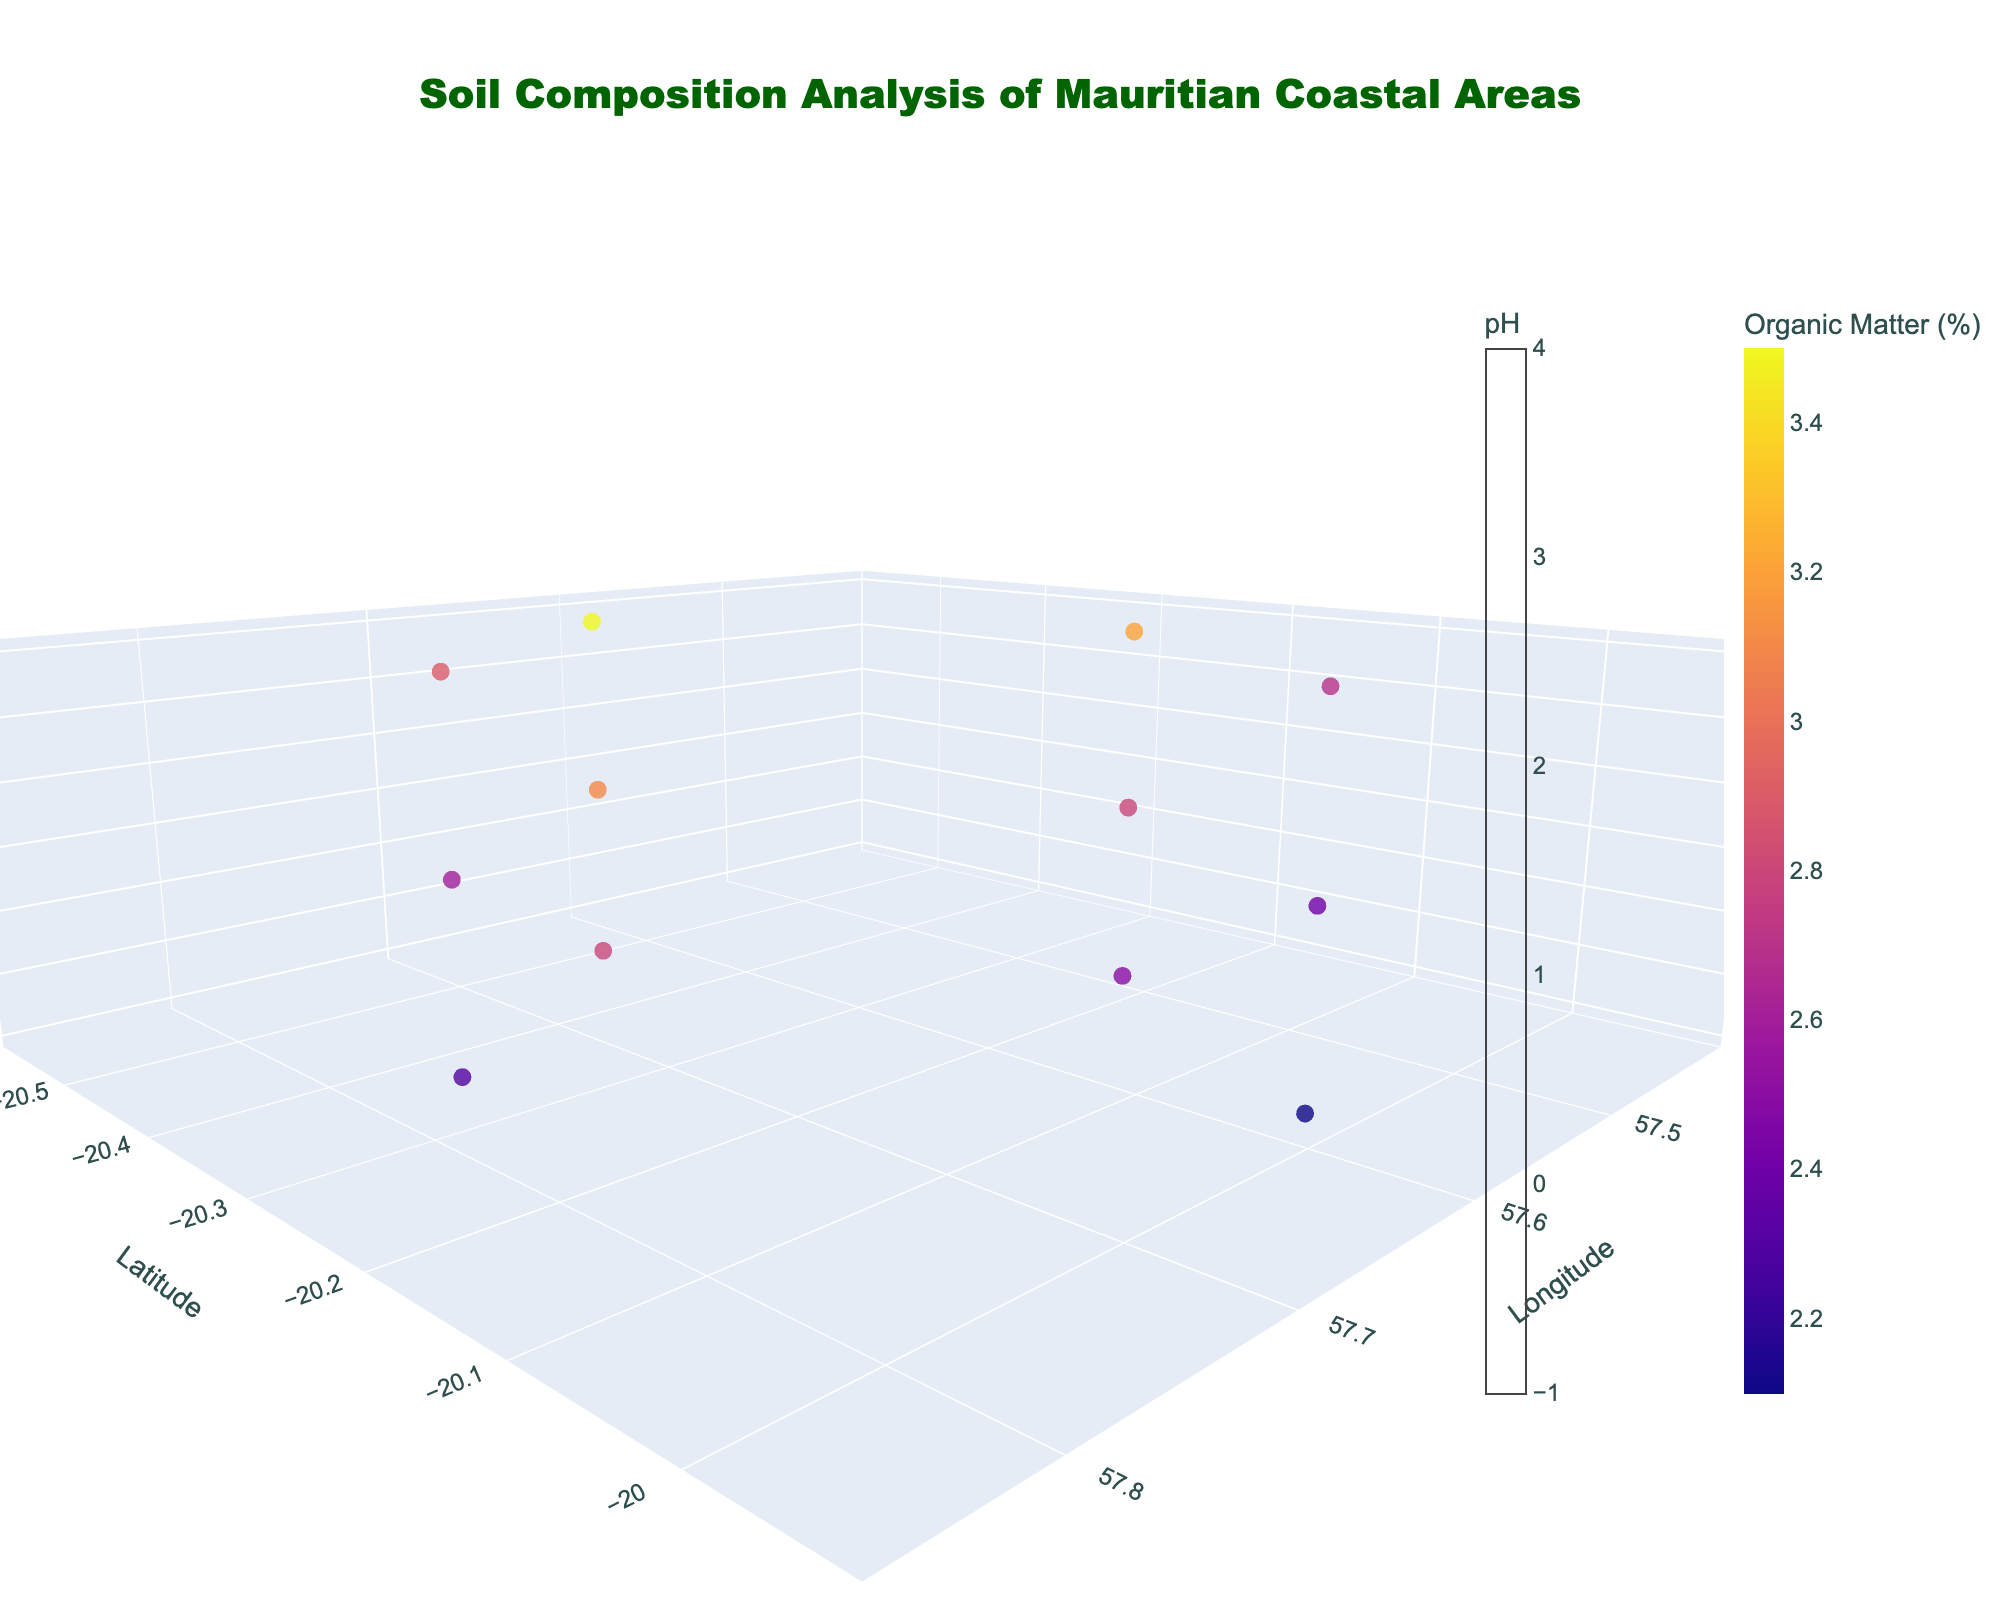Which parameter is represented by the color scale on the volume plot? The color scale on the volume plot is labeled 'pH', indicating that it represents the pH values of the soil at different depths and locations
Answer: pH What is the range of depths displayed on the plot? The depth range is indicated by the z-axis, which ranges from 0 cm to a bit over 60 cm, as the maximum depth value in the dataset is 60 cm.
Answer: 0 to 60 cm How does the organic matter content change with increasing depth at the location with a latitude of -20.2167? At the location with latitude -20.2167, the organic matter content decreases as depth increases: 3.2% at 0 cm, 2.8% at 30 cm, and 2.5% at 60 cm
Answer: It decreases Which location has the highest calcium content at the 0 cm depth? Comparing the calcium content at 0 cm depth for each location, the highest value is at the location with a latitude of -20.0167 and longitude of 57.5833, where the calcium content is 1400
Answer: -20.0167, 57.5833 At which depth does the pH decrease the most for the location at latitude -20.3500? For latitude -20.3500, the pH values at 0 cm, 30 cm, and 60 cm are 8.1, 7.9, and 7.7 respectively. The pH decreases the most between 0 cm and 30 cm (0.2 units) compared to between 30 cm and 60 cm (0.2 units)
Answer: 0 cm - 30 cm What is the average pH value for the topsoil (0 cm depth) across all locations? To find the average pH for the topsoil: (7.8 + 8.1 + 7.5 + 8.3) / 4 = 7.925
Answer: 7.925 Which location has the most consistent organic matter content with depth changes? The location with latitude -20.0167 and longitude 57.5833 has relatively smaller changes in organic matter content across depths (2.7% to 2.1%) compared to other locations with greater variances
Answer: -20.0167, 57.5833 What is the relationship between depth and magnesium content at the latitude of -20.4833? At -20.4833, as depth increases, magnesium content decreases: from 170 at 0 cm to 160 at 30 cm, and 150 at 60 cm, showing a downward trend
Answer: It decreases Compare the pH values at 60 cm depth for the locations with latitudes -20.2167 and -20.3500. Which one is higher? At 60 cm depth, the pH value at -20.2167 is 7.4, and at -20.3500 it is 7.7. Thus, the pH value at -20.3500 is higher
Answer: -20.3500 How do the sodium levels at surface level (0 cm) compare between the southernmost and northernmost locations? The southernmost location is -20.4833, 57.6333 with sodium level 300, and the northernmost location is -20.0167, 57.5833 with sodium level 380. The northernmost location has higher sodium levels
Answer: The northernmost location has higher sodium levels 